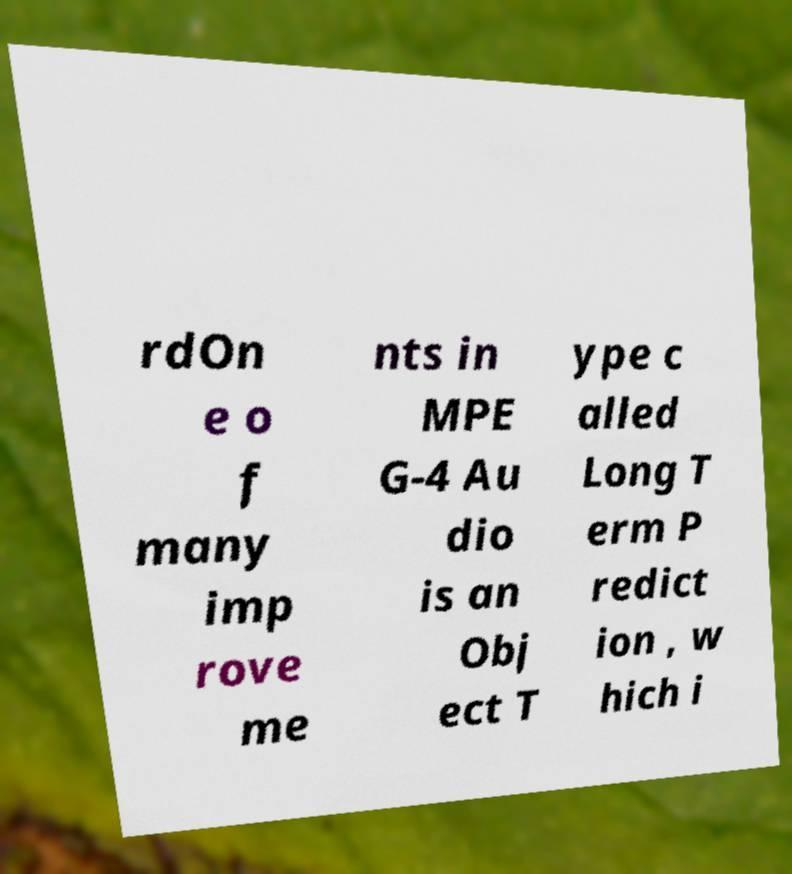Could you assist in decoding the text presented in this image and type it out clearly? rdOn e o f many imp rove me nts in MPE G-4 Au dio is an Obj ect T ype c alled Long T erm P redict ion , w hich i 